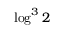Convert formula to latex. <formula><loc_0><loc_0><loc_500><loc_500>\log ^ { 3 } 2</formula> 